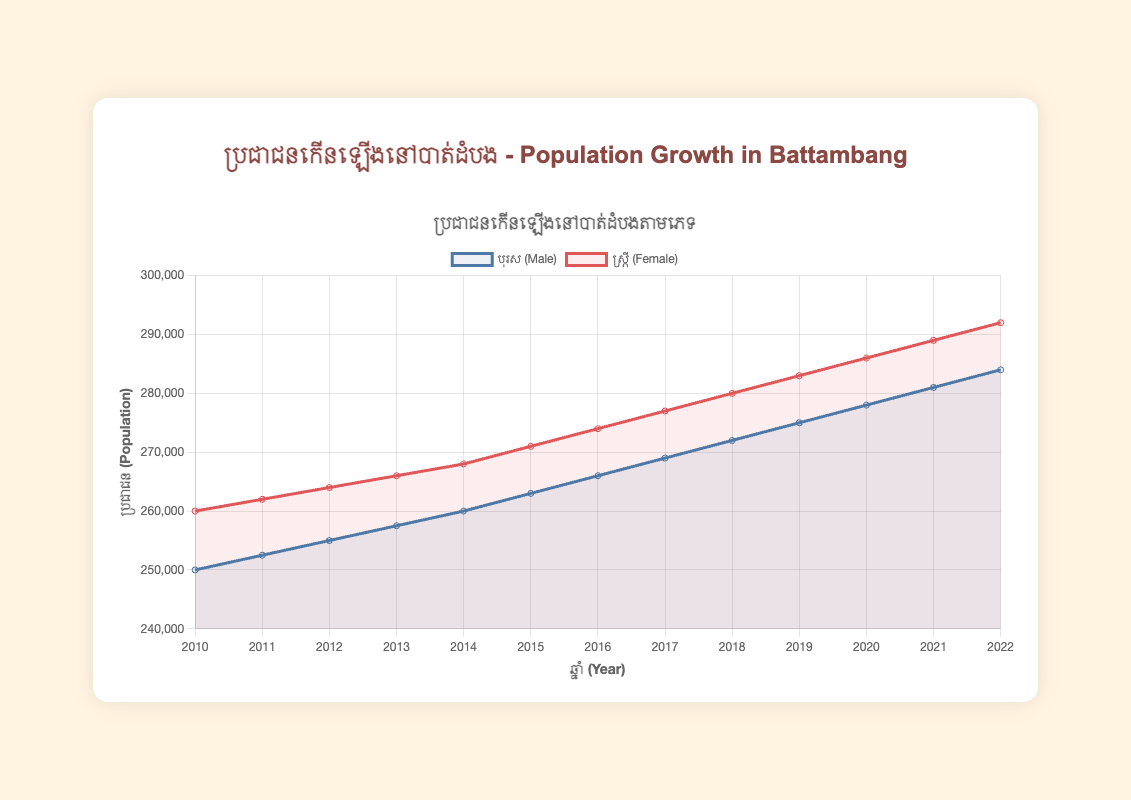How does the population of males and females compare in 2015? The figure shows population data for males and females in specific years. For 2015, the population of males is 263,000, and the population of females is 271,000. Comparing these numbers, females outnumber males.
Answer: Females have a higher population in 2015 What's the total population of Battambang in 2010? The total population can be calculated by summing the male and female populations for the given year. In 2010, the male population is 250,000 and the female population is 260,000. Therefore, the total population is 250,000 + 260,000 = 510,000.
Answer: 510,000 Between which consecutive years did the female population experience the highest growth? By looking at the increase in the female population for each consecutive year, the highest growth is from 2015 (271,000) to 2016 (274,000), which is an increase of 3,000.
Answer: 2015 to 2016 Which year shows a higher population increase for males compared to the previous year? To determine this, we compare the population increase year-over-year for males. Comparing the increases, the highest difference is between 2019 (275,000) and 2020 (278,000), which is an increase of 3,000.
Answer: 2020 What's the average annual population growth for males from 2010 to 2022? To find the average growth, we calculate the total growth and then divide by the number of years. Total growth from 250,000 in 2010 to 284,000 in 2022 is 284,000 - 250,000 = 34,000 over 12 years. The average annual growth is 34,000 / 12 ≈ 2,833.33.
Answer: 2,833.33 By how much did the male population increase from 2010 to 2013? The male population in 2010 is 250,000 and in 2013 it's 257,500, so the increase is 257,500 - 250,000 = 7,500.
Answer: 7,500 What is the ratio of the female population to the male population in 2021? For 2021, the female population is 289,000 and the male population is 281,000. The ratio is 289,000 / 281,000 ≈ 1.03.
Answer: 1.03 